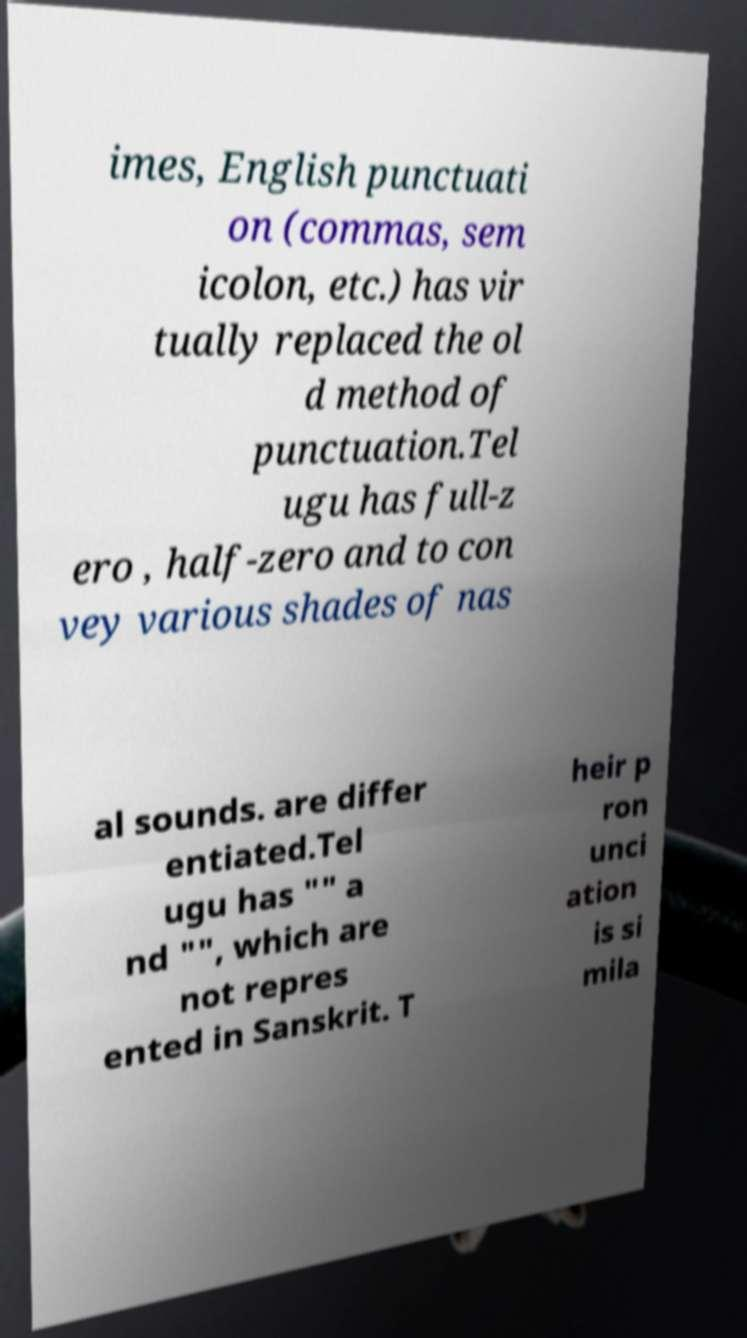For documentation purposes, I need the text within this image transcribed. Could you provide that? imes, English punctuati on (commas, sem icolon, etc.) has vir tually replaced the ol d method of punctuation.Tel ugu has full-z ero , half-zero and to con vey various shades of nas al sounds. are differ entiated.Tel ugu has "" a nd "", which are not repres ented in Sanskrit. T heir p ron unci ation is si mila 